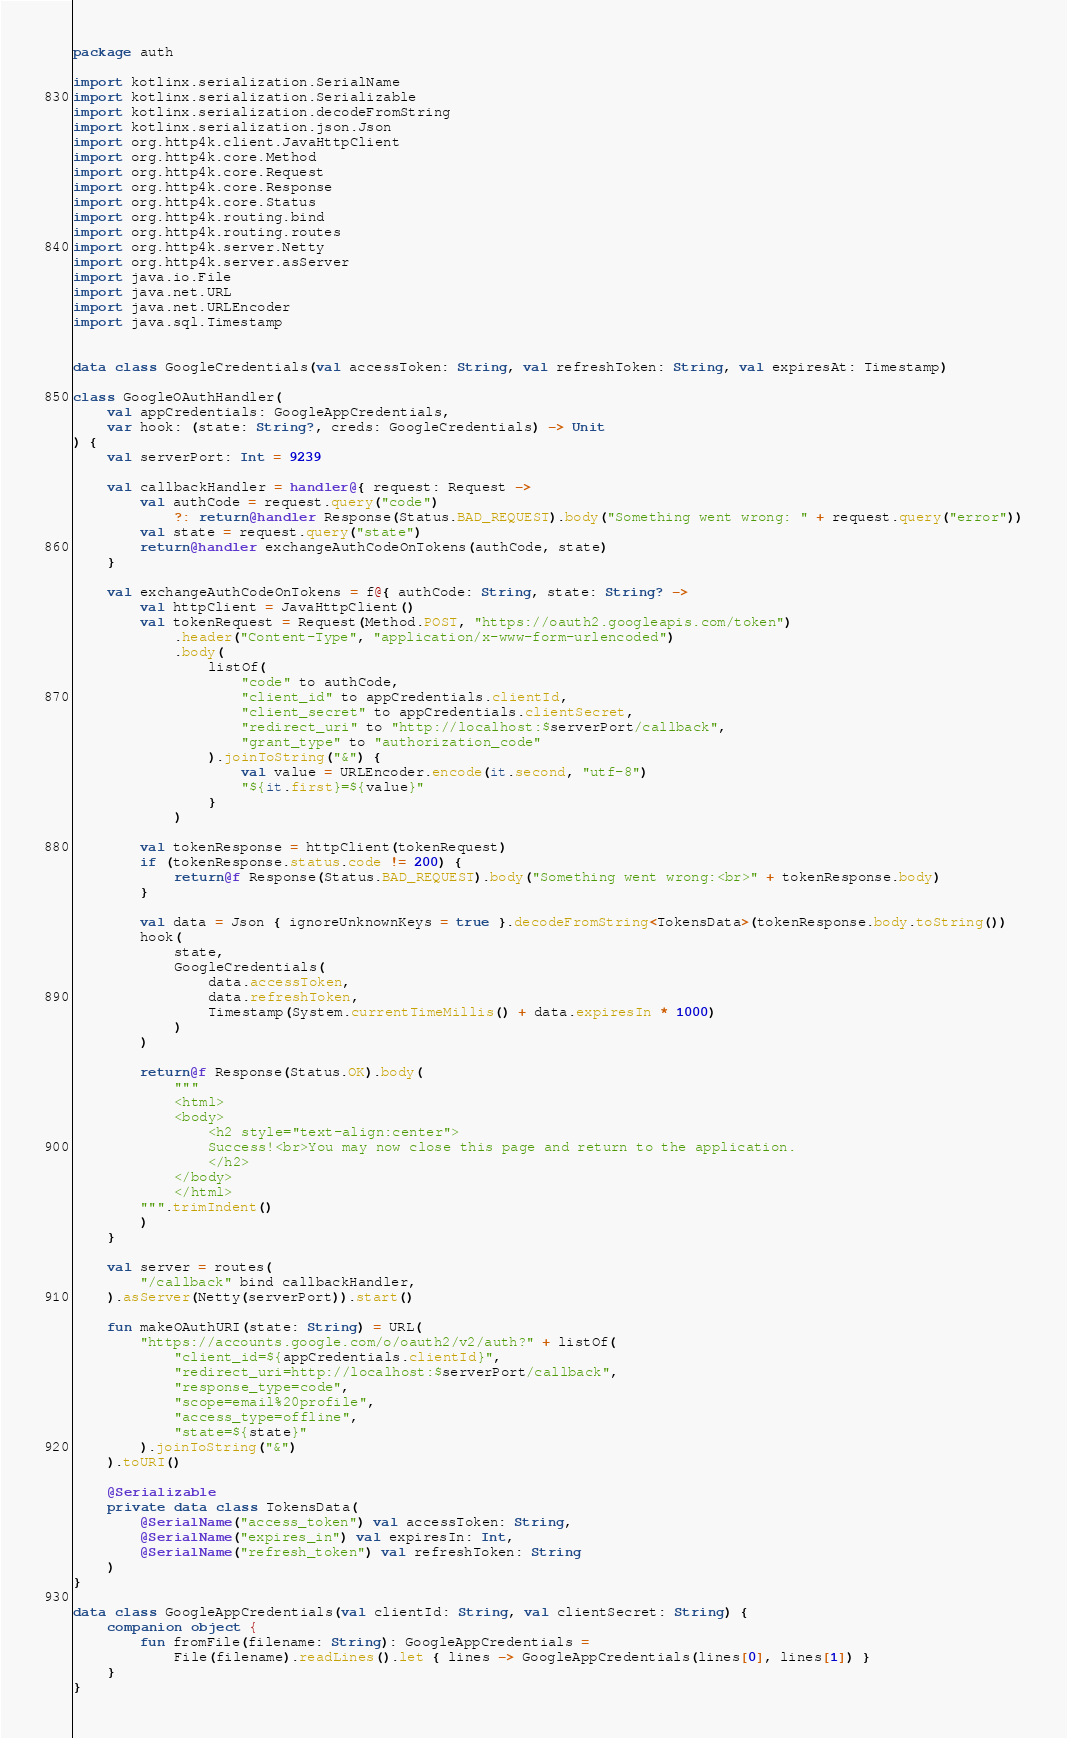Convert code to text. <code><loc_0><loc_0><loc_500><loc_500><_Kotlin_>package auth

import kotlinx.serialization.SerialName
import kotlinx.serialization.Serializable
import kotlinx.serialization.decodeFromString
import kotlinx.serialization.json.Json
import org.http4k.client.JavaHttpClient
import org.http4k.core.Method
import org.http4k.core.Request
import org.http4k.core.Response
import org.http4k.core.Status
import org.http4k.routing.bind
import org.http4k.routing.routes
import org.http4k.server.Netty
import org.http4k.server.asServer
import java.io.File
import java.net.URL
import java.net.URLEncoder
import java.sql.Timestamp


data class GoogleCredentials(val accessToken: String, val refreshToken: String, val expiresAt: Timestamp)

class GoogleOAuthHandler(
    val appCredentials: GoogleAppCredentials,
    var hook: (state: String?, creds: GoogleCredentials) -> Unit
) {
    val serverPort: Int = 9239

    val callbackHandler = handler@{ request: Request ->
        val authCode = request.query("code")
            ?: return@handler Response(Status.BAD_REQUEST).body("Something went wrong: " + request.query("error"))
        val state = request.query("state")
        return@handler exchangeAuthCodeOnTokens(authCode, state)
    }

    val exchangeAuthCodeOnTokens = f@{ authCode: String, state: String? ->
        val httpClient = JavaHttpClient()
        val tokenRequest = Request(Method.POST, "https://oauth2.googleapis.com/token")
            .header("Content-Type", "application/x-www-form-urlencoded")
            .body(
                listOf(
                    "code" to authCode,
                    "client_id" to appCredentials.clientId,
                    "client_secret" to appCredentials.clientSecret,
                    "redirect_uri" to "http://localhost:$serverPort/callback",
                    "grant_type" to "authorization_code"
                ).joinToString("&") {
                    val value = URLEncoder.encode(it.second, "utf-8")
                    "${it.first}=${value}"
                }
            )

        val tokenResponse = httpClient(tokenRequest)
        if (tokenResponse.status.code != 200) {
            return@f Response(Status.BAD_REQUEST).body("Something went wrong:<br>" + tokenResponse.body)
        }

        val data = Json { ignoreUnknownKeys = true }.decodeFromString<TokensData>(tokenResponse.body.toString())
        hook(
            state,
            GoogleCredentials(
                data.accessToken,
                data.refreshToken,
                Timestamp(System.currentTimeMillis() + data.expiresIn * 1000)
            )
        )

        return@f Response(Status.OK).body(
            """
            <html>
            <body>
                <h2 style="text-align:center">
                Success!<br>You may now close this page and return to the application.
                </h2>
            </body>
            </html>
        """.trimIndent()
        )
    }

    val server = routes(
        "/callback" bind callbackHandler,
    ).asServer(Netty(serverPort)).start()

    fun makeOAuthURI(state: String) = URL(
        "https://accounts.google.com/o/oauth2/v2/auth?" + listOf(
            "client_id=${appCredentials.clientId}",
            "redirect_uri=http://localhost:$serverPort/callback",
            "response_type=code",
            "scope=email%20profile",
            "access_type=offline",
            "state=${state}"
        ).joinToString("&")
    ).toURI()

    @Serializable
    private data class TokensData(
        @SerialName("access_token") val accessToken: String,
        @SerialName("expires_in") val expiresIn: Int,
        @SerialName("refresh_token") val refreshToken: String
    )
}

data class GoogleAppCredentials(val clientId: String, val clientSecret: String) {
    companion object {
        fun fromFile(filename: String): GoogleAppCredentials =
            File(filename).readLines().let { lines -> GoogleAppCredentials(lines[0], lines[1]) }
    }
}</code> 